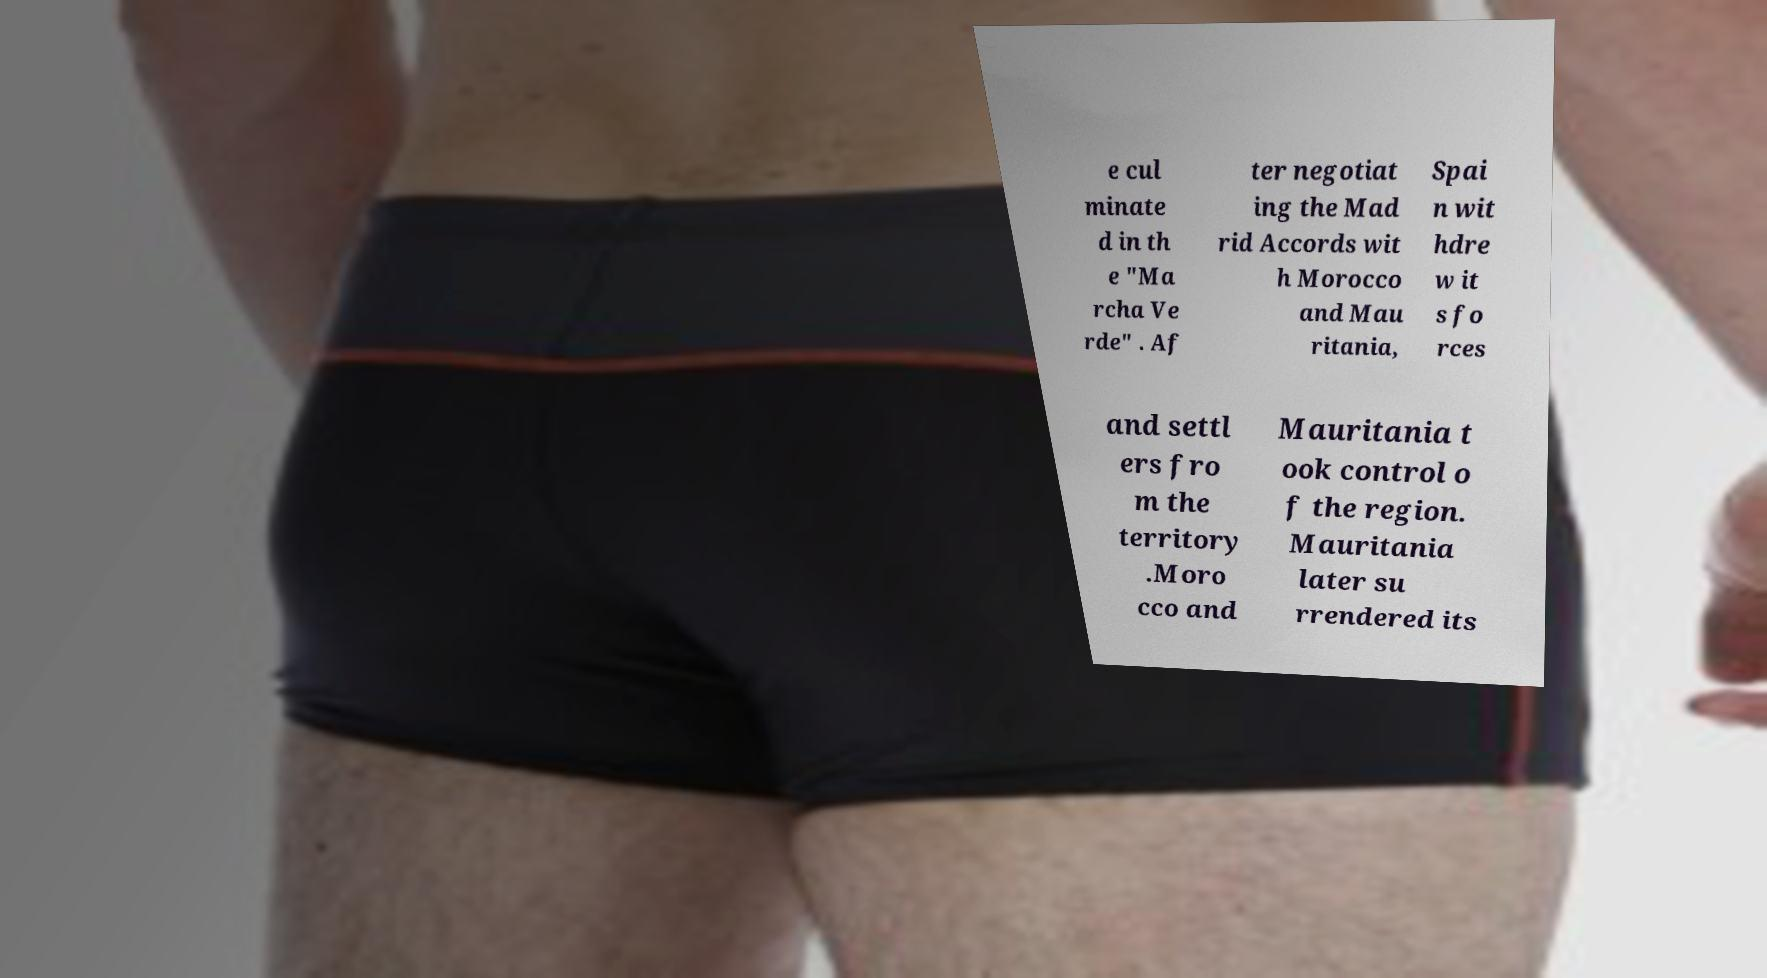Please identify and transcribe the text found in this image. e cul minate d in th e "Ma rcha Ve rde" . Af ter negotiat ing the Mad rid Accords wit h Morocco and Mau ritania, Spai n wit hdre w it s fo rces and settl ers fro m the territory .Moro cco and Mauritania t ook control o f the region. Mauritania later su rrendered its 